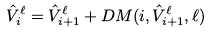<formula> <loc_0><loc_0><loc_500><loc_500>\hat { V } ^ { \ell } _ { i } = \hat { V } ^ { \ell } _ { i + 1 } + D M ( i , \hat { V } ^ { \ell } _ { i + 1 } , \ell )</formula> 